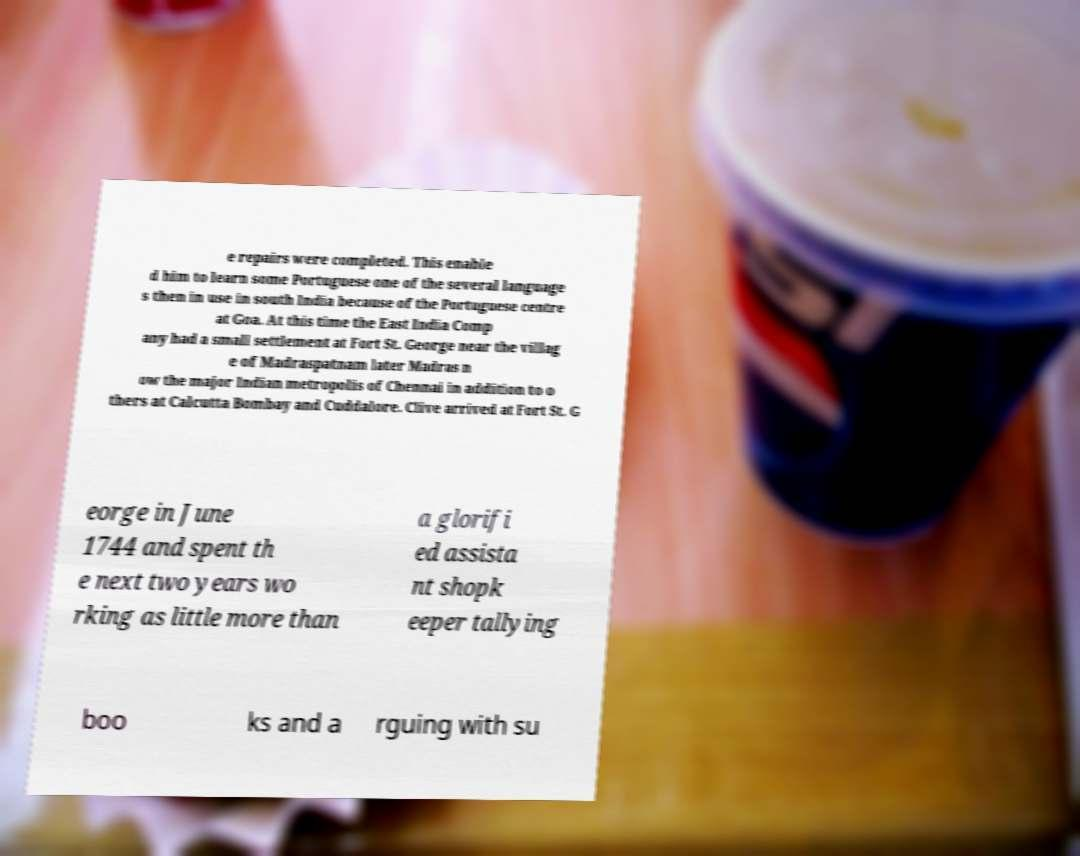There's text embedded in this image that I need extracted. Can you transcribe it verbatim? e repairs were completed. This enable d him to learn some Portuguese one of the several language s then in use in south India because of the Portuguese centre at Goa. At this time the East India Comp any had a small settlement at Fort St. George near the villag e of Madraspatnam later Madras n ow the major Indian metropolis of Chennai in addition to o thers at Calcutta Bombay and Cuddalore. Clive arrived at Fort St. G eorge in June 1744 and spent th e next two years wo rking as little more than a glorifi ed assista nt shopk eeper tallying boo ks and a rguing with su 